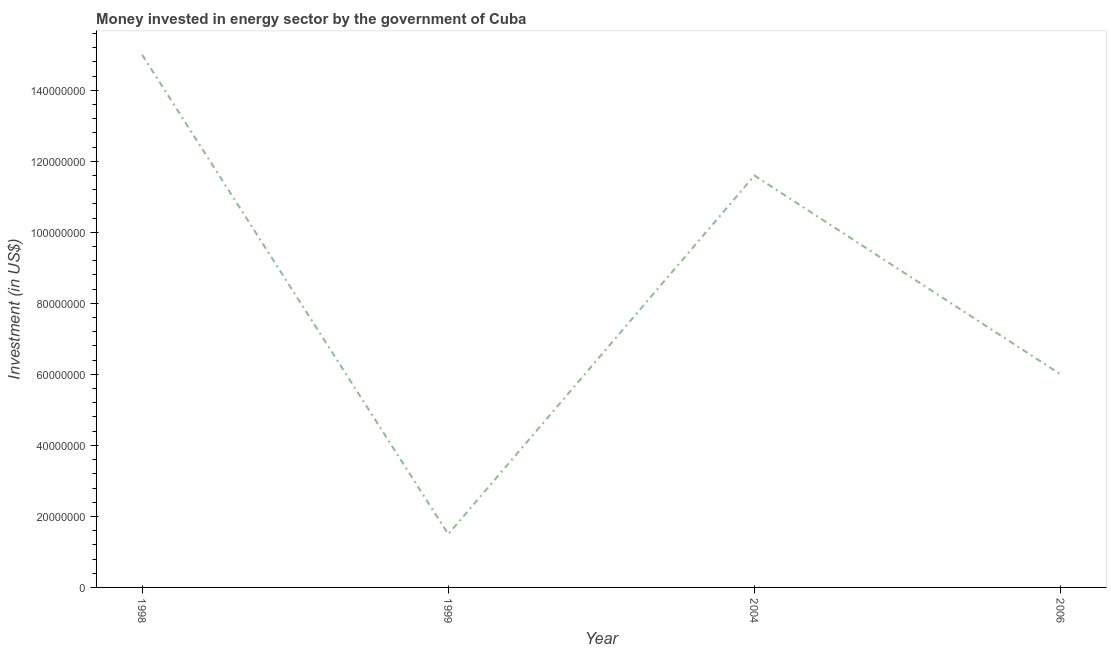What is the investment in energy in 2006?
Give a very brief answer. 6.00e+07. Across all years, what is the maximum investment in energy?
Give a very brief answer. 1.50e+08. Across all years, what is the minimum investment in energy?
Keep it short and to the point. 1.50e+07. In which year was the investment in energy maximum?
Make the answer very short. 1998. In which year was the investment in energy minimum?
Provide a short and direct response. 1999. What is the sum of the investment in energy?
Your answer should be compact. 3.41e+08. What is the difference between the investment in energy in 1999 and 2006?
Your response must be concise. -4.50e+07. What is the average investment in energy per year?
Provide a succinct answer. 8.52e+07. What is the median investment in energy?
Provide a succinct answer. 8.80e+07. In how many years, is the investment in energy greater than 16000000 US$?
Offer a very short reply. 3. What is the difference between the highest and the second highest investment in energy?
Provide a succinct answer. 3.40e+07. Is the sum of the investment in energy in 1998 and 2004 greater than the maximum investment in energy across all years?
Your answer should be compact. Yes. What is the difference between the highest and the lowest investment in energy?
Give a very brief answer. 1.35e+08. In how many years, is the investment in energy greater than the average investment in energy taken over all years?
Provide a short and direct response. 2. Does the investment in energy monotonically increase over the years?
Your answer should be very brief. No. How many lines are there?
Keep it short and to the point. 1. Are the values on the major ticks of Y-axis written in scientific E-notation?
Provide a succinct answer. No. Does the graph contain grids?
Provide a succinct answer. No. What is the title of the graph?
Your response must be concise. Money invested in energy sector by the government of Cuba. What is the label or title of the X-axis?
Provide a succinct answer. Year. What is the label or title of the Y-axis?
Offer a terse response. Investment (in US$). What is the Investment (in US$) of 1998?
Offer a very short reply. 1.50e+08. What is the Investment (in US$) in 1999?
Your answer should be very brief. 1.50e+07. What is the Investment (in US$) of 2004?
Offer a terse response. 1.16e+08. What is the Investment (in US$) of 2006?
Provide a short and direct response. 6.00e+07. What is the difference between the Investment (in US$) in 1998 and 1999?
Your answer should be very brief. 1.35e+08. What is the difference between the Investment (in US$) in 1998 and 2004?
Your answer should be compact. 3.40e+07. What is the difference between the Investment (in US$) in 1998 and 2006?
Provide a short and direct response. 9.00e+07. What is the difference between the Investment (in US$) in 1999 and 2004?
Your response must be concise. -1.01e+08. What is the difference between the Investment (in US$) in 1999 and 2006?
Keep it short and to the point. -4.50e+07. What is the difference between the Investment (in US$) in 2004 and 2006?
Your answer should be very brief. 5.60e+07. What is the ratio of the Investment (in US$) in 1998 to that in 1999?
Offer a very short reply. 10. What is the ratio of the Investment (in US$) in 1998 to that in 2004?
Offer a terse response. 1.29. What is the ratio of the Investment (in US$) in 1998 to that in 2006?
Provide a succinct answer. 2.5. What is the ratio of the Investment (in US$) in 1999 to that in 2004?
Give a very brief answer. 0.13. What is the ratio of the Investment (in US$) in 1999 to that in 2006?
Your response must be concise. 0.25. What is the ratio of the Investment (in US$) in 2004 to that in 2006?
Your answer should be very brief. 1.93. 